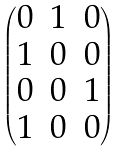<formula> <loc_0><loc_0><loc_500><loc_500>\begin{pmatrix} 0 & 1 & 0 \\ 1 & 0 & 0 \\ 0 & 0 & 1 \\ 1 & 0 & 0 \\ \end{pmatrix}</formula> 